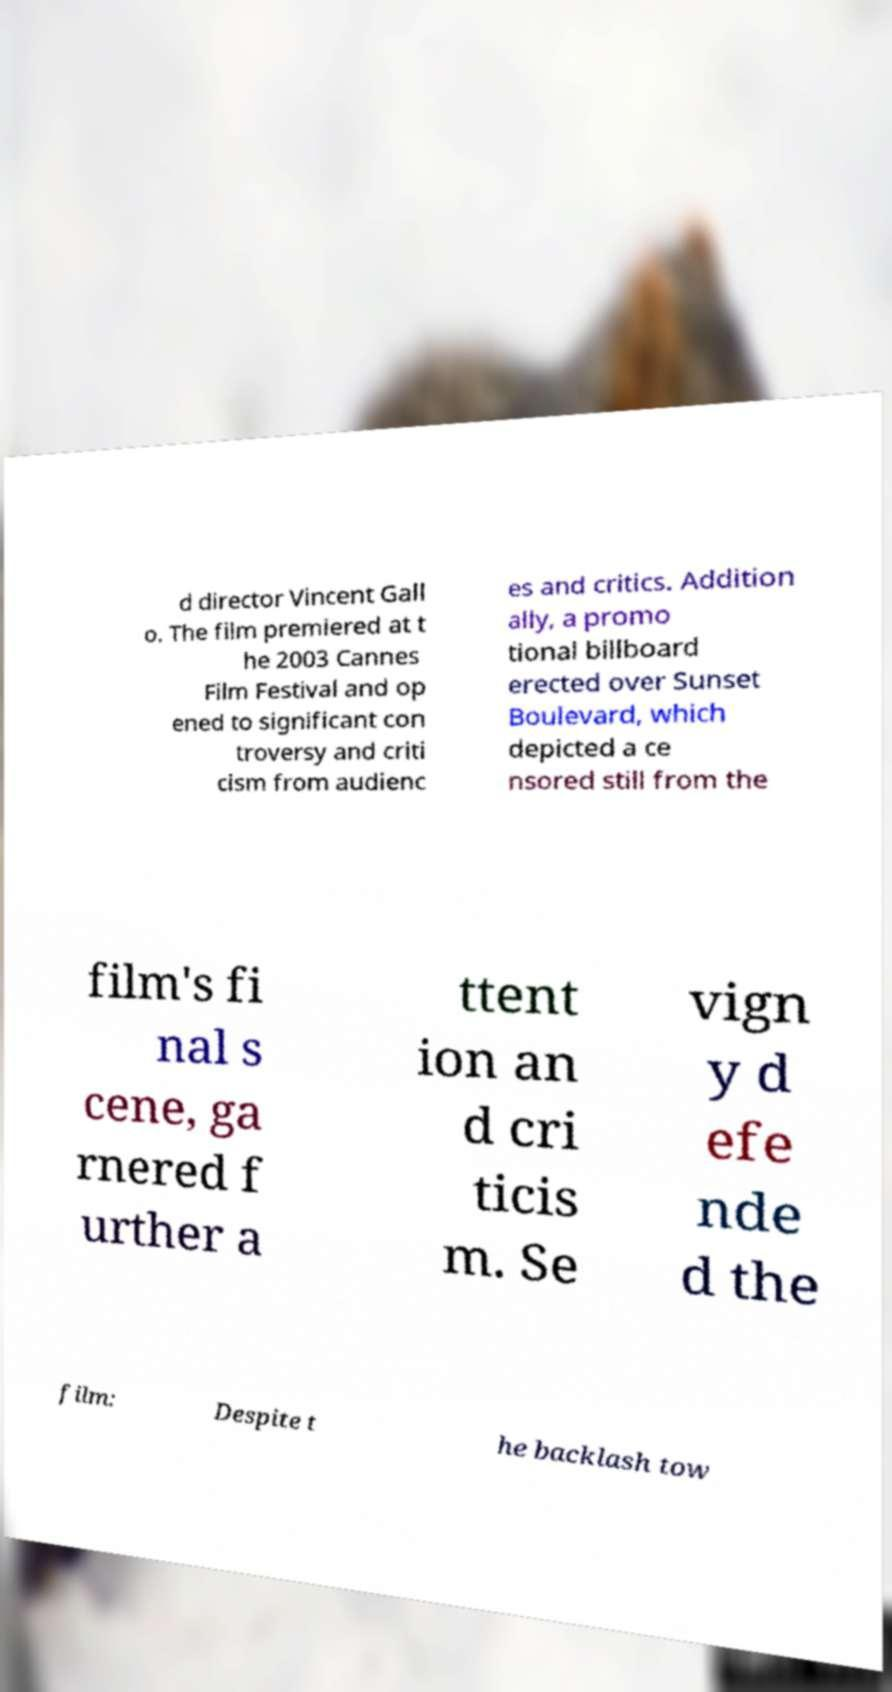For documentation purposes, I need the text within this image transcribed. Could you provide that? d director Vincent Gall o. The film premiered at t he 2003 Cannes Film Festival and op ened to significant con troversy and criti cism from audienc es and critics. Addition ally, a promo tional billboard erected over Sunset Boulevard, which depicted a ce nsored still from the film's fi nal s cene, ga rnered f urther a ttent ion an d cri ticis m. Se vign y d efe nde d the film: Despite t he backlash tow 